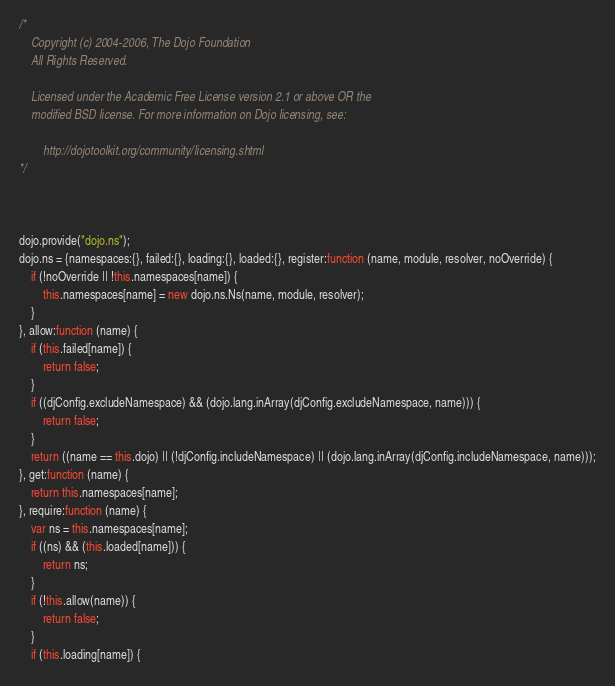<code> <loc_0><loc_0><loc_500><loc_500><_JavaScript_>/*
	Copyright (c) 2004-2006, The Dojo Foundation
	All Rights Reserved.

	Licensed under the Academic Free License version 2.1 or above OR the
	modified BSD license. For more information on Dojo licensing, see:

		http://dojotoolkit.org/community/licensing.shtml
*/



dojo.provide("dojo.ns");
dojo.ns = {namespaces:{}, failed:{}, loading:{}, loaded:{}, register:function (name, module, resolver, noOverride) {
	if (!noOverride || !this.namespaces[name]) {
		this.namespaces[name] = new dojo.ns.Ns(name, module, resolver);
	}
}, allow:function (name) {
	if (this.failed[name]) {
		return false;
	}
	if ((djConfig.excludeNamespace) && (dojo.lang.inArray(djConfig.excludeNamespace, name))) {
		return false;
	}
	return ((name == this.dojo) || (!djConfig.includeNamespace) || (dojo.lang.inArray(djConfig.includeNamespace, name)));
}, get:function (name) {
	return this.namespaces[name];
}, require:function (name) {
	var ns = this.namespaces[name];
	if ((ns) && (this.loaded[name])) {
		return ns;
	}
	if (!this.allow(name)) {
		return false;
	}
	if (this.loading[name]) {</code> 